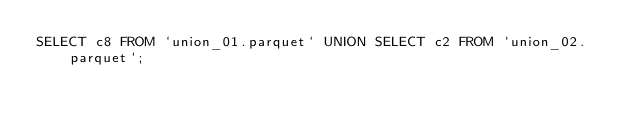<code> <loc_0><loc_0><loc_500><loc_500><_SQL_>SELECT c8 FROM `union_01.parquet` UNION SELECT c2 FROM `union_02.parquet`;</code> 